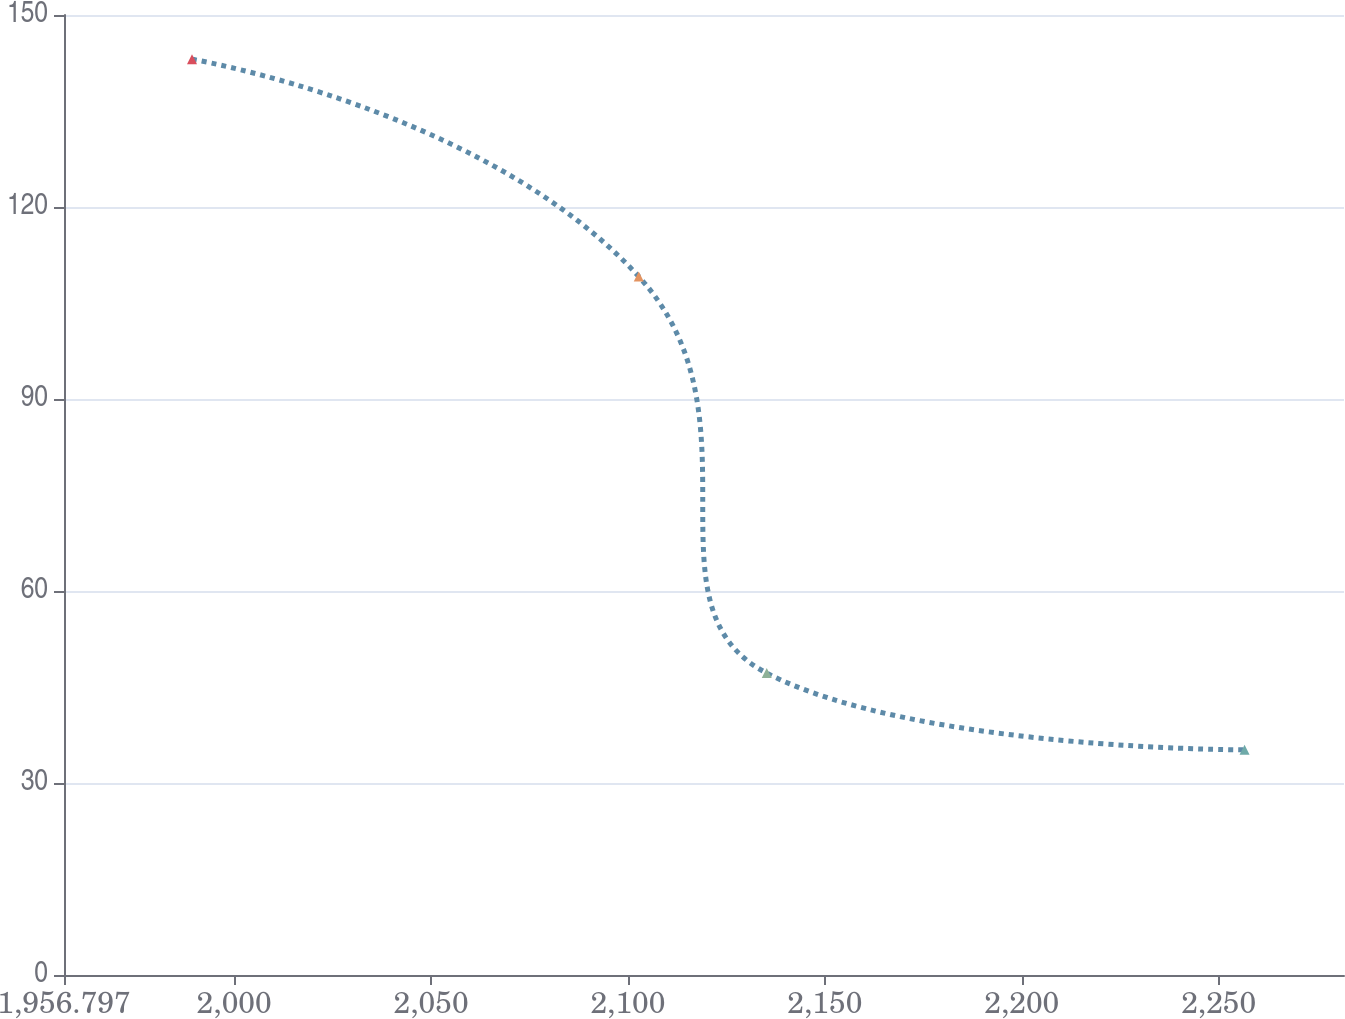<chart> <loc_0><loc_0><loc_500><loc_500><line_chart><ecel><fcel>Unnamed: 1<nl><fcel>1989.3<fcel>143.09<nl><fcel>2102.74<fcel>109.14<nl><fcel>2135.24<fcel>47.17<nl><fcel>2256.58<fcel>35.18<nl><fcel>2314.33<fcel>23.19<nl></chart> 